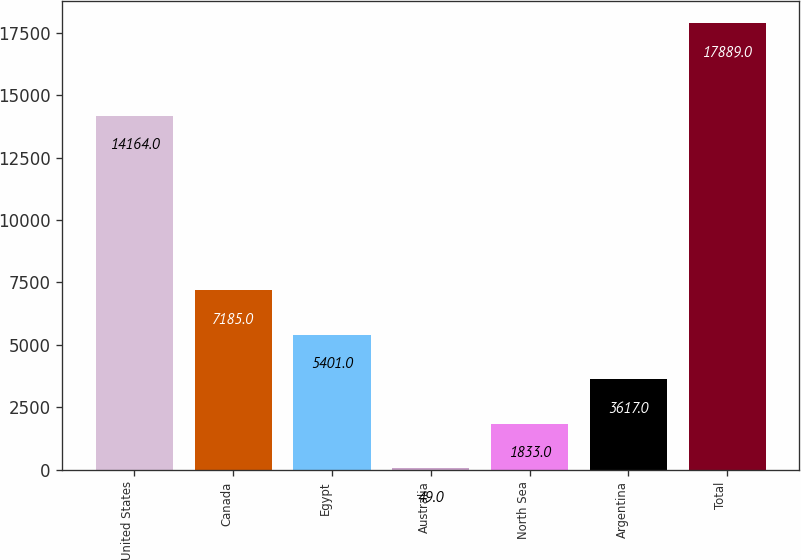Convert chart to OTSL. <chart><loc_0><loc_0><loc_500><loc_500><bar_chart><fcel>United States<fcel>Canada<fcel>Egypt<fcel>Australia<fcel>North Sea<fcel>Argentina<fcel>Total<nl><fcel>14164<fcel>7185<fcel>5401<fcel>49<fcel>1833<fcel>3617<fcel>17889<nl></chart> 